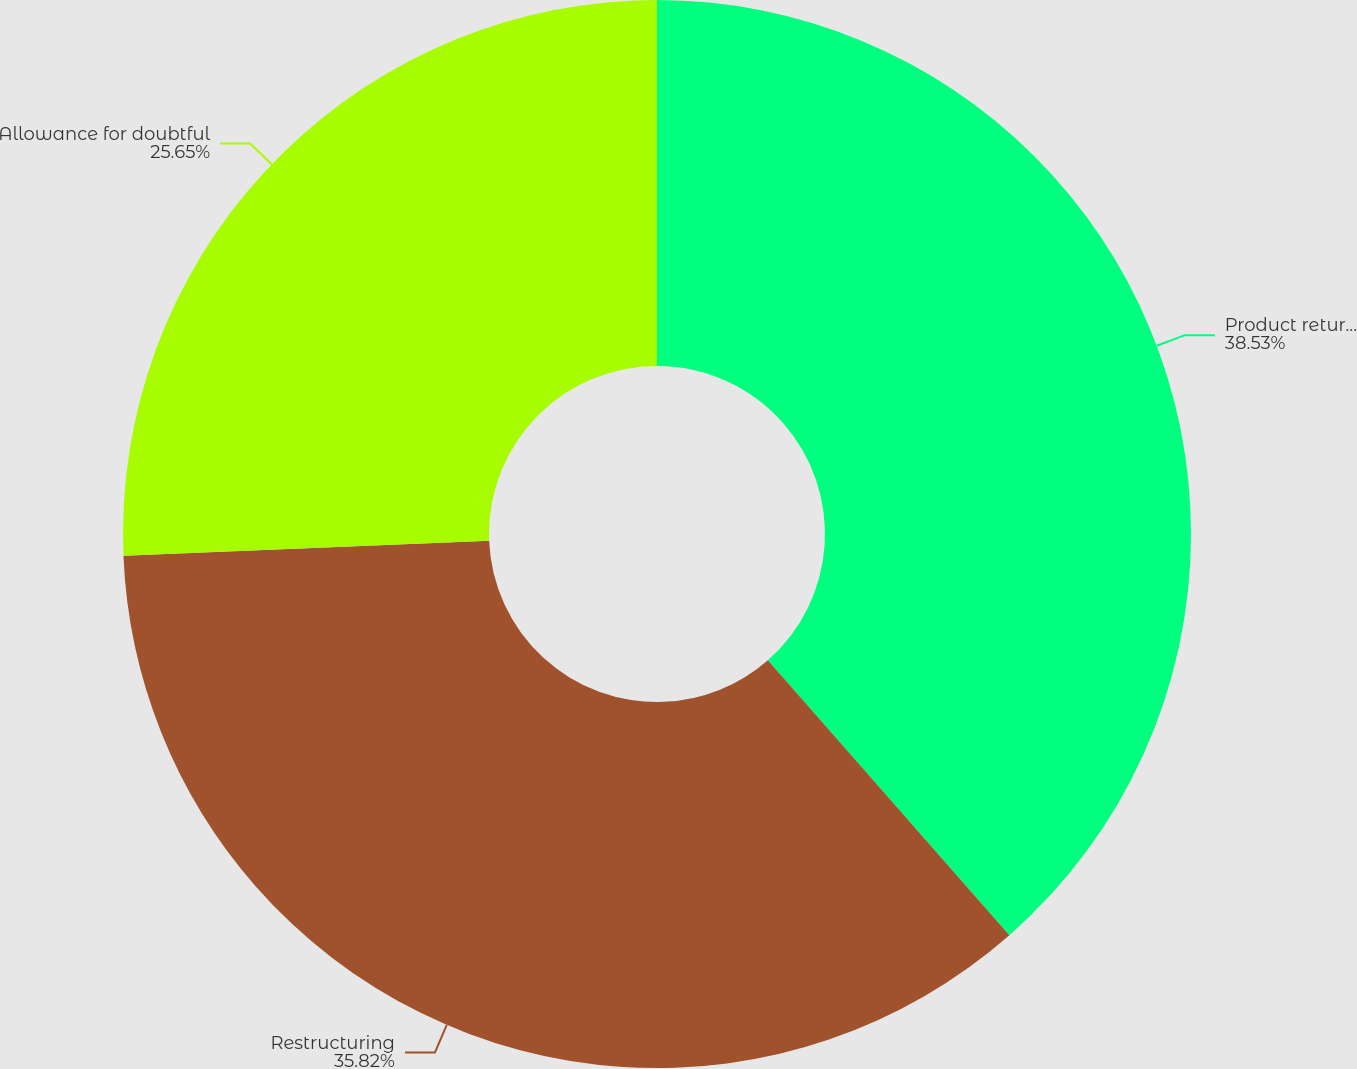Convert chart to OTSL. <chart><loc_0><loc_0><loc_500><loc_500><pie_chart><fcel>Product returns reserve<fcel>Restructuring<fcel>Allowance for doubtful<nl><fcel>38.53%<fcel>35.82%<fcel>25.65%<nl></chart> 